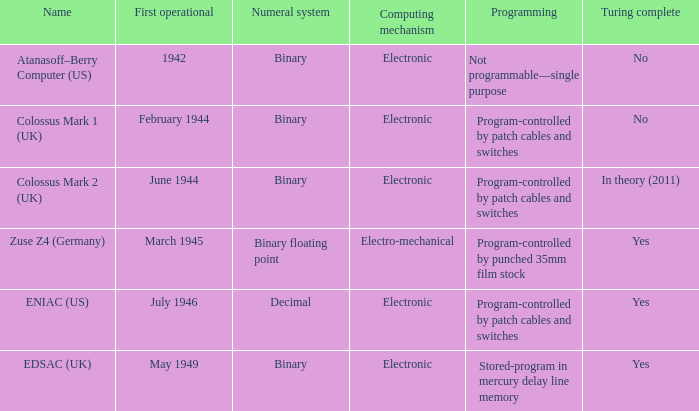What's the computing mechanbeingm with first operational being february 1944 Electronic. 